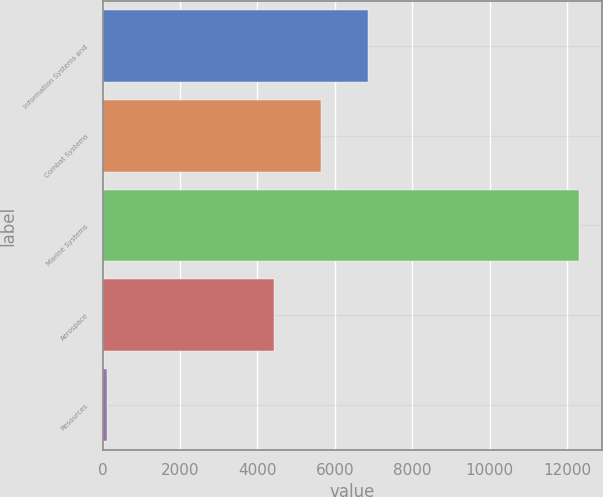Convert chart. <chart><loc_0><loc_0><loc_500><loc_500><bar_chart><fcel>Information Systems and<fcel>Combat Systems<fcel>Marine Systems<fcel>Aerospace<fcel>Resources<nl><fcel>6853<fcel>5634.5<fcel>12298<fcel>4416<fcel>113<nl></chart> 